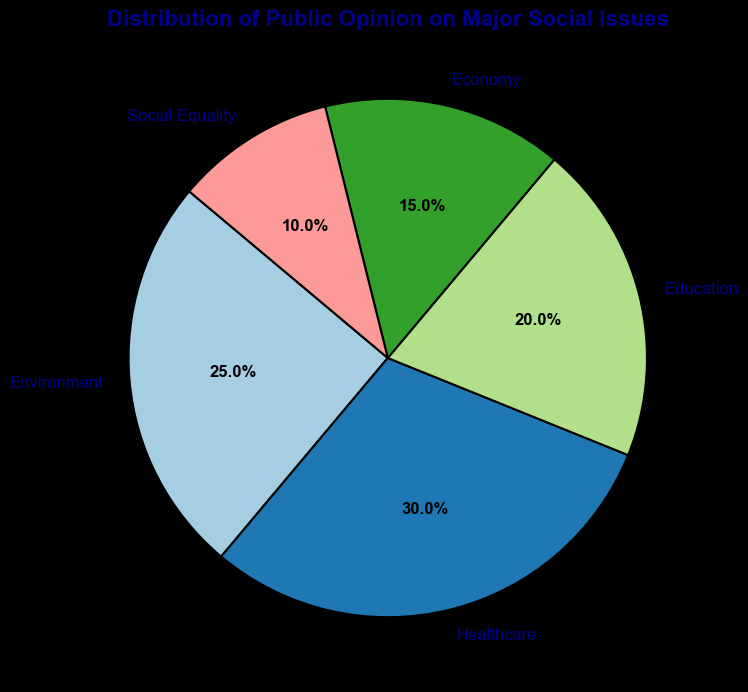Which social issue has the highest percentage of public opinion? The largest segment of the pie chart represents the social issue with the highest percentage. By looking at the sizes, Healthcare occupies the largest portion.
Answer: Healthcare What is the combined percentage of public opinion on Environment and Education? To find the combined percentage, sum the percentages for Environment and Education: 25% (Environment) + 20% (Education).
Answer: 45% Which social issue is represented by the smallest section of the pie chart? The smallest segment of the pie chart corresponds to the issue with the lowest percentage. Social Equality is the smallest section with 10%.
Answer: Social Equality How much greater is the percentage of Healthcare compared to Social Equality? Subtract the percentage of Social Equality from Healthcare: 30% (Healthcare) - 10% (Social Equality).
Answer: 20% What is the average percentage of public opinion for all the social issues? Add all the percentages together and divide by the number of social issues: (25% + 30% + 20% + 15% + 10%) / 5. This equals 100% / 5.
Answer: 20% Which two social issues combined are equal to the percentage of Environment? Look for two segments that sum to 25%. Social Equality (10%) and Economy (15%) together make 25%.
Answer: Social Equality and Economy Which social issues have a higher percentage of public opinion than Economy? Identify segments larger than 15%. Environment (25%), Healthcare (30%), and Education (20%) all have higher percentages.
Answer: Environment, Healthcare, Education If the percentage of public opinion on Social Equality doubled, how would it compare to Healthcare? Doubling Social Equality's percentage: 10% * 2 = 20%. Healthcare is at 30%, so Healthcare would still be higher.
Answer: Healthcare would be higher Is the percentage of public opinion on the Economy greater than half of the percentage on Healthcare? Compare half of Healthcare's percentage to Economy: 30% / 2 = 15%, which is equal to Economy's 15%.
Answer: No (it's equal) Which sector is represented by the color green? Pick out the sector visually represented by green in the pie chart. Without the actual chart to reference colors, this question can't be directly answered.
Answer: Not answerable without the figure 